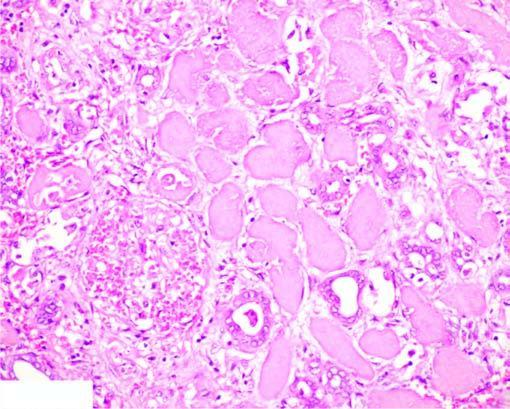re the affected area on right outline of tubules still maintained?
Answer the question using a single word or phrase. Yes 